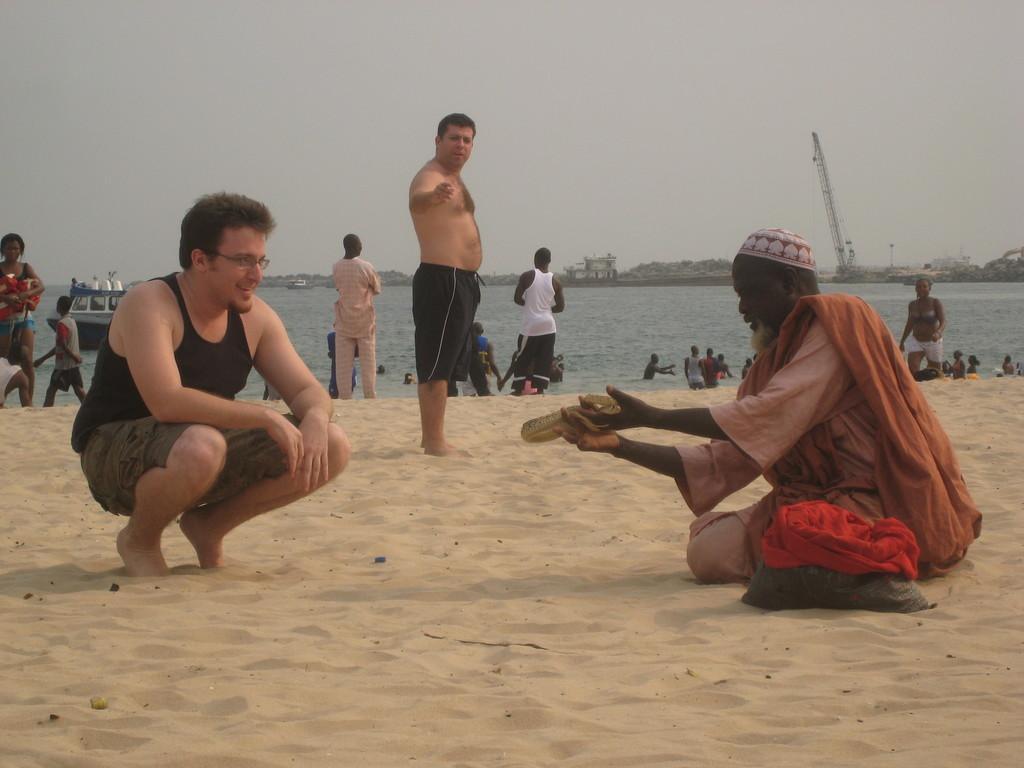Please provide a concise description of this image. This picture is clicked outside the city. On the right there is a person holding an object and sitting on the ground and there is a bag placed on the ground. On the left there is a man smiling and squatting on the ground. In the center we can see the group of people seems to be standing on the ground. In the background there is a sky, metal rods and group of persons in the water body and we can see the boats in the water body. 